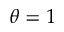<formula> <loc_0><loc_0><loc_500><loc_500>\theta = 1</formula> 